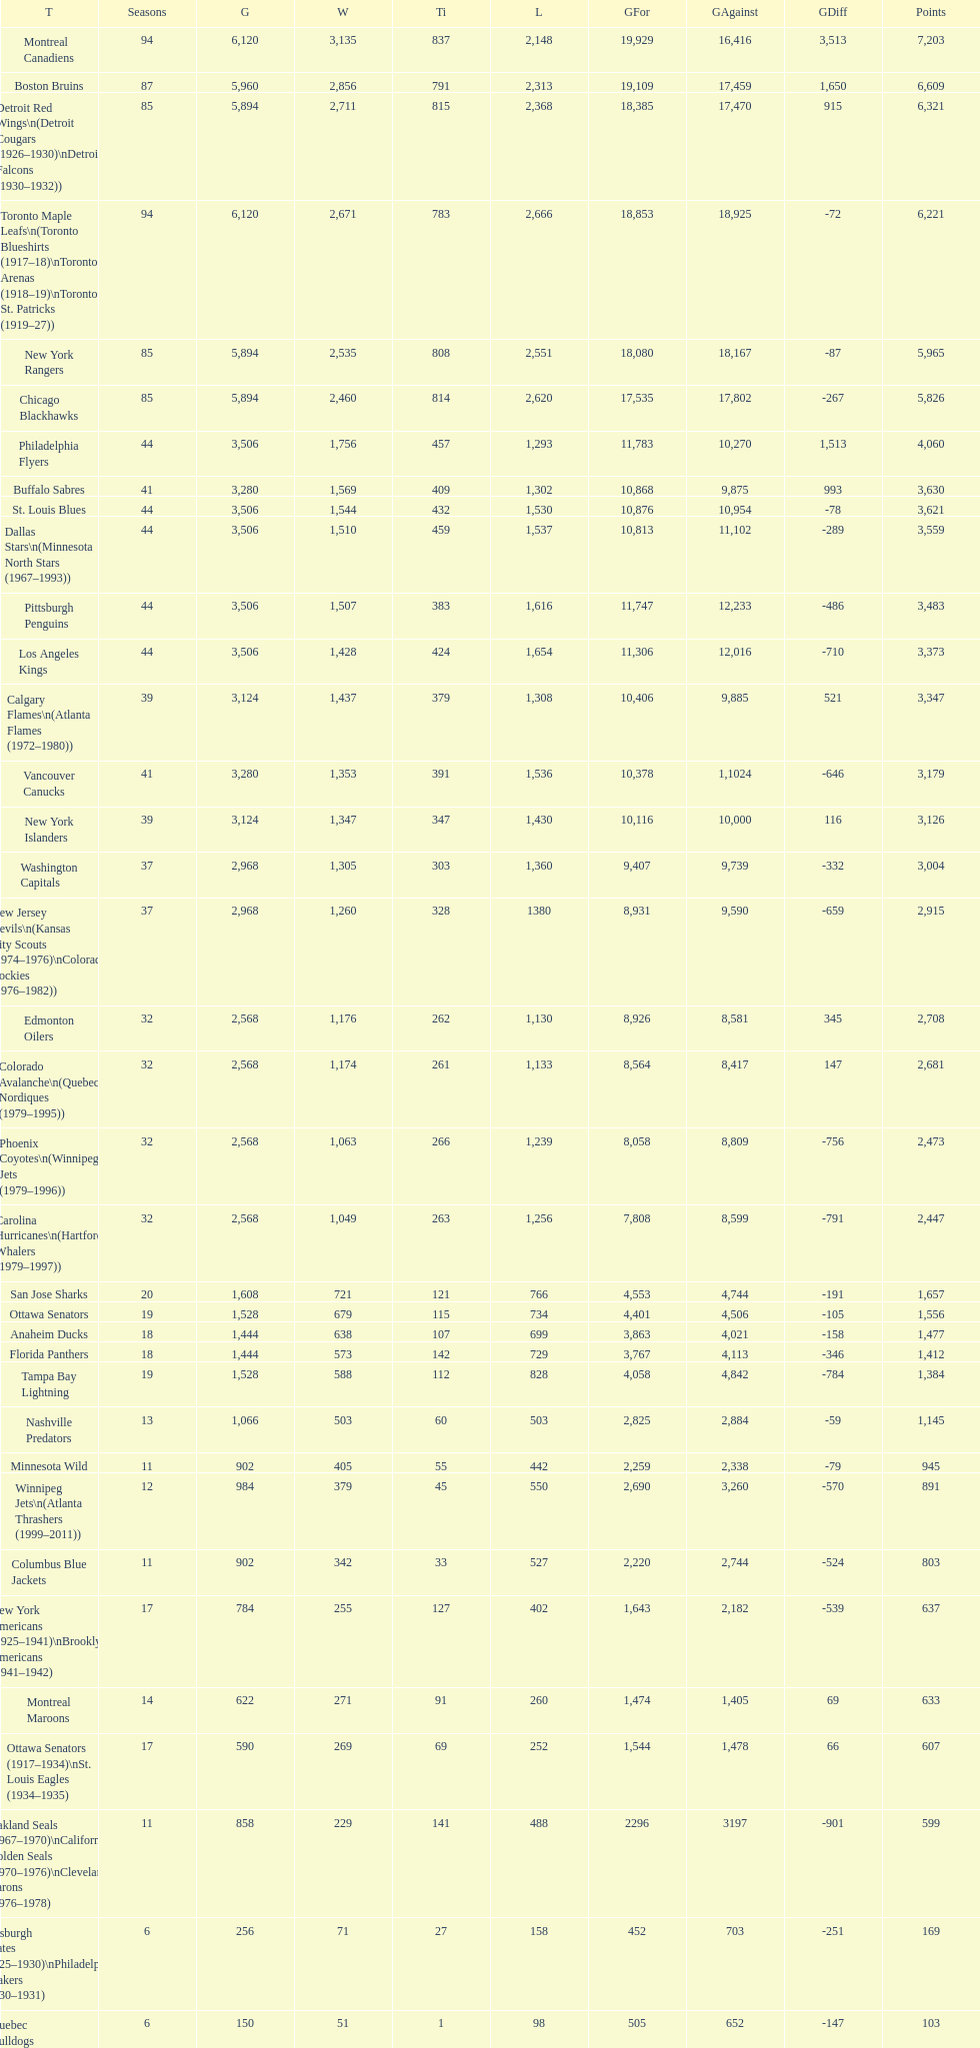How many teams have won more than 1,500 games? 11. 